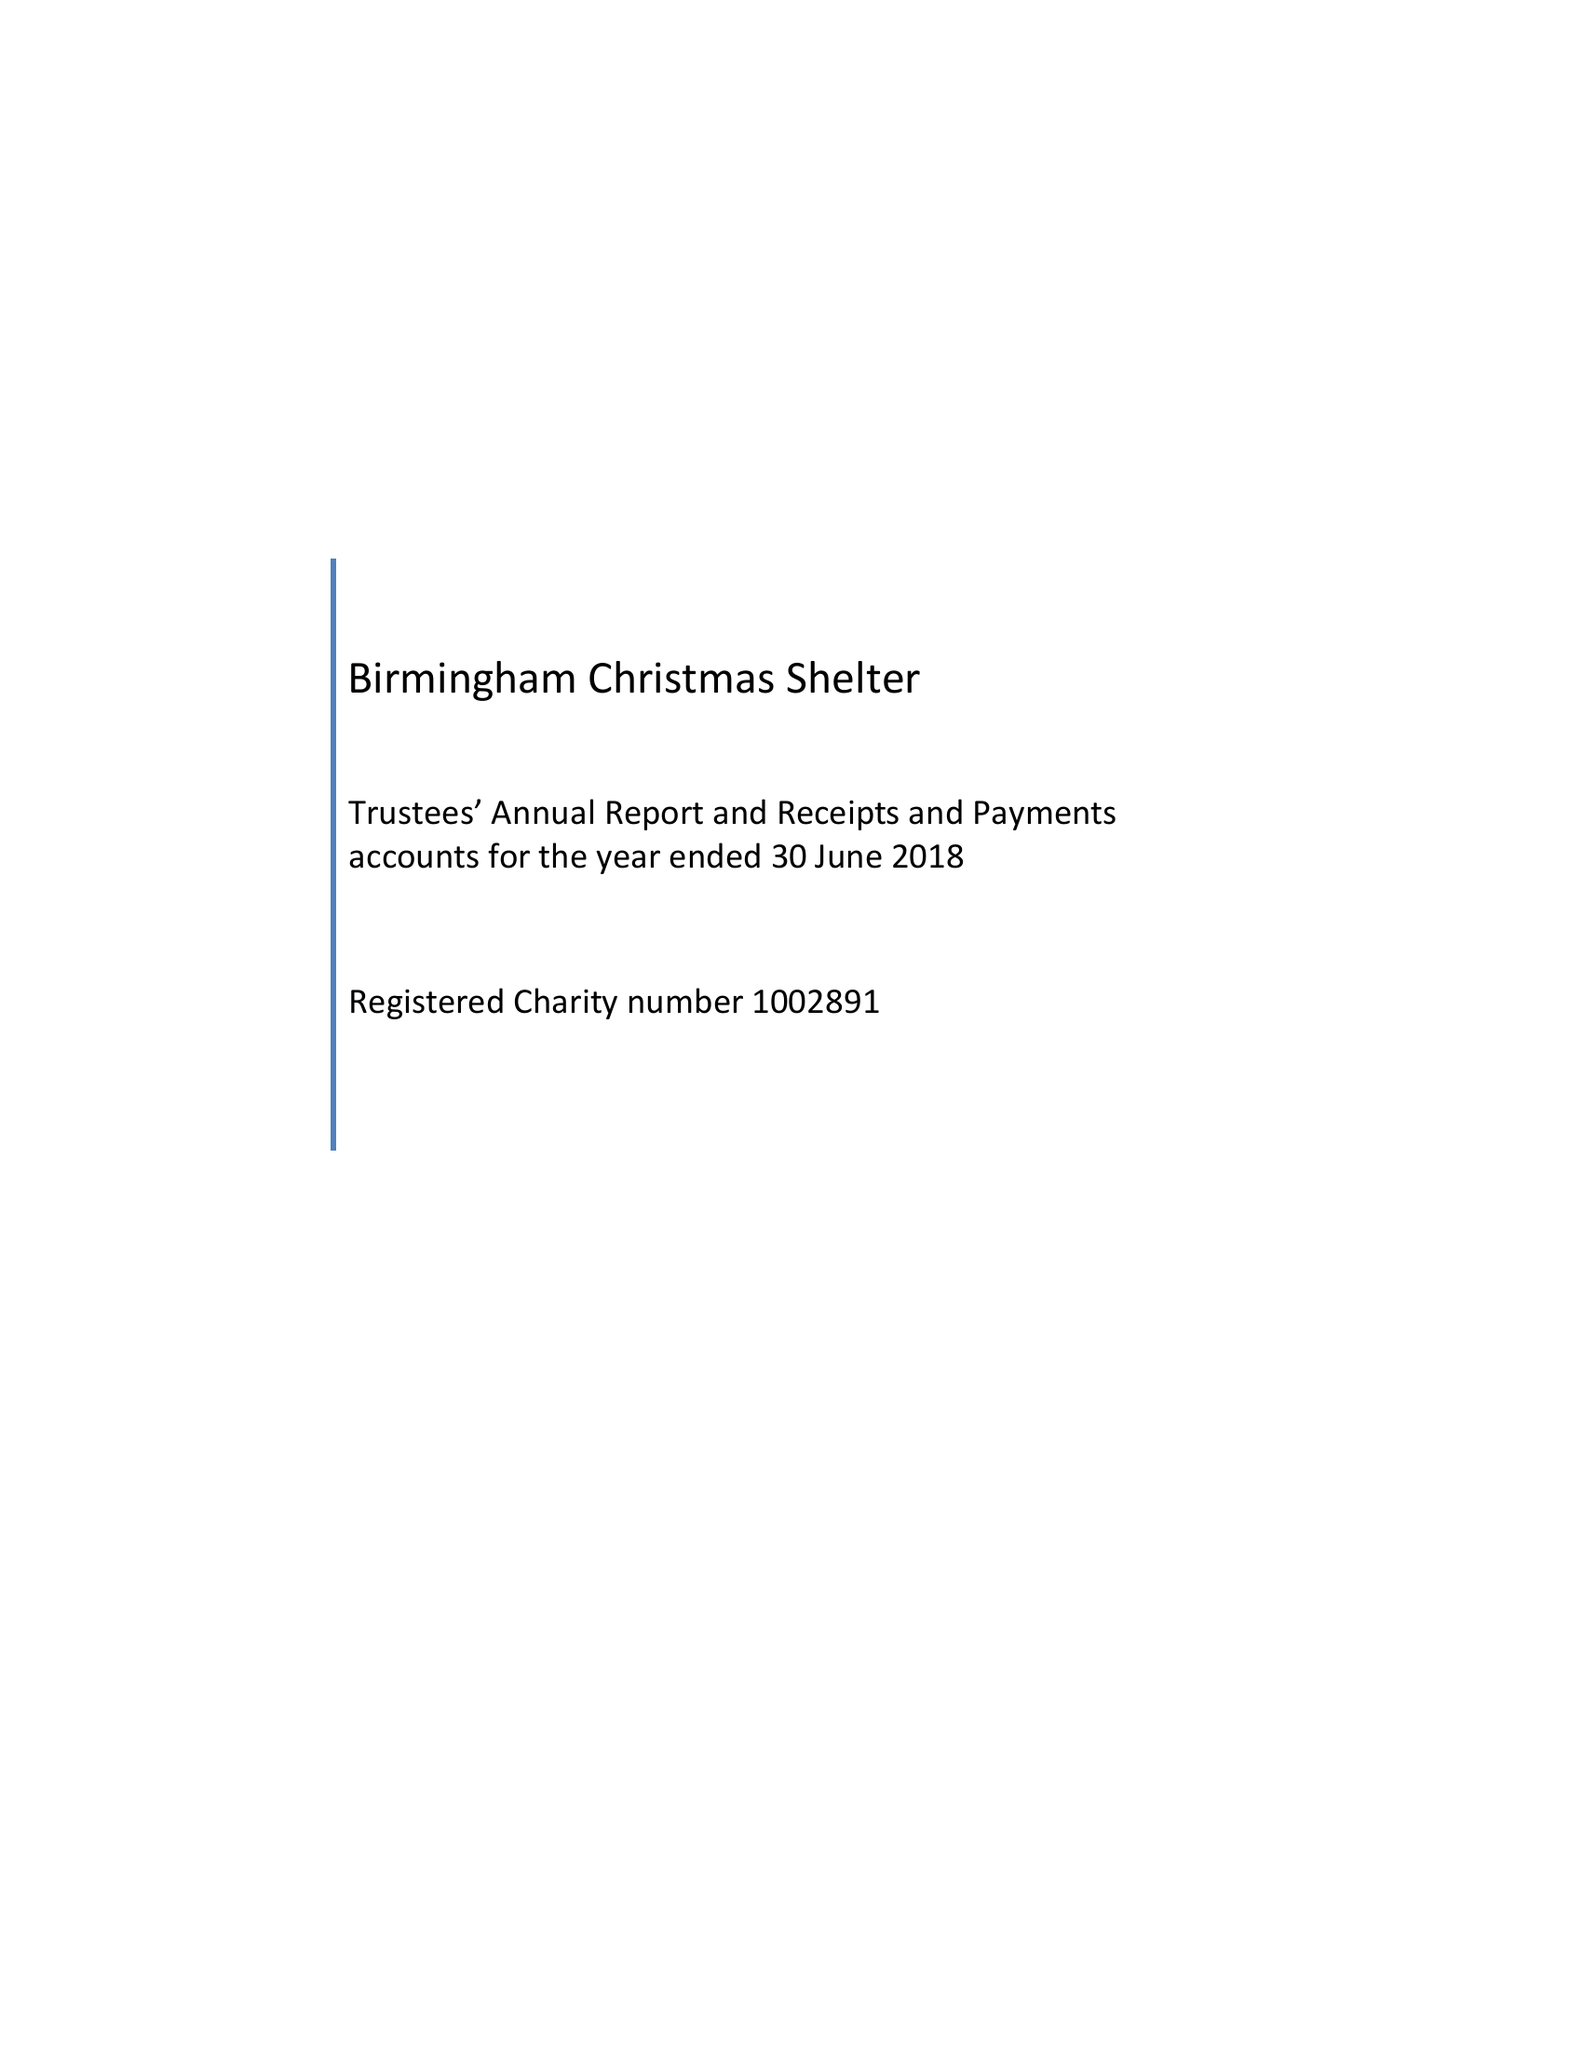What is the value for the report_date?
Answer the question using a single word or phrase. 2018-06-30 